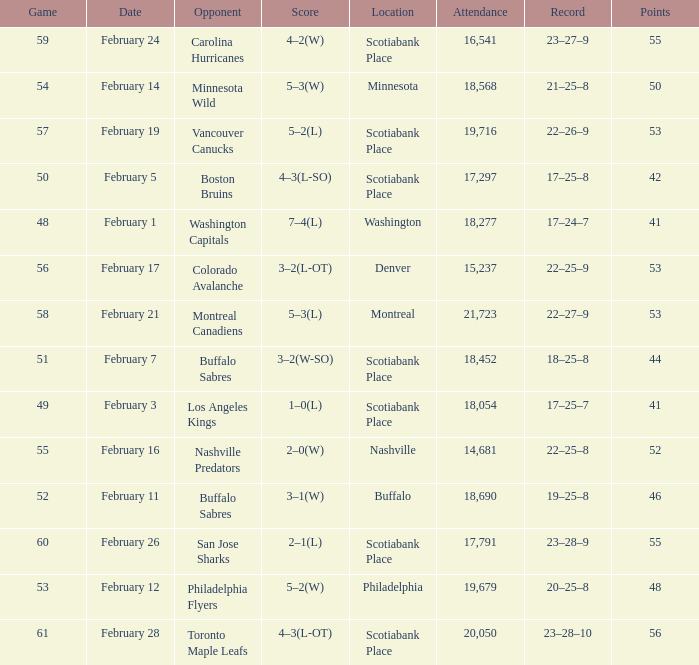What sum of game has an attendance of 18,690? 52.0. I'm looking to parse the entire table for insights. Could you assist me with that? {'header': ['Game', 'Date', 'Opponent', 'Score', 'Location', 'Attendance', 'Record', 'Points'], 'rows': [['59', 'February 24', 'Carolina Hurricanes', '4–2(W)', 'Scotiabank Place', '16,541', '23–27–9', '55'], ['54', 'February 14', 'Minnesota Wild', '5–3(W)', 'Minnesota', '18,568', '21–25–8', '50'], ['57', 'February 19', 'Vancouver Canucks', '5–2(L)', 'Scotiabank Place', '19,716', '22–26–9', '53'], ['50', 'February 5', 'Boston Bruins', '4–3(L-SO)', 'Scotiabank Place', '17,297', '17–25–8', '42'], ['48', 'February 1', 'Washington Capitals', '7–4(L)', 'Washington', '18,277', '17–24–7', '41'], ['56', 'February 17', 'Colorado Avalanche', '3–2(L-OT)', 'Denver', '15,237', '22–25–9', '53'], ['58', 'February 21', 'Montreal Canadiens', '5–3(L)', 'Montreal', '21,723', '22–27–9', '53'], ['51', 'February 7', 'Buffalo Sabres', '3–2(W-SO)', 'Scotiabank Place', '18,452', '18–25–8', '44'], ['49', 'February 3', 'Los Angeles Kings', '1–0(L)', 'Scotiabank Place', '18,054', '17–25–7', '41'], ['55', 'February 16', 'Nashville Predators', '2–0(W)', 'Nashville', '14,681', '22–25–8', '52'], ['52', 'February 11', 'Buffalo Sabres', '3–1(W)', 'Buffalo', '18,690', '19–25–8', '46'], ['60', 'February 26', 'San Jose Sharks', '2–1(L)', 'Scotiabank Place', '17,791', '23–28–9', '55'], ['53', 'February 12', 'Philadelphia Flyers', '5–2(W)', 'Philadelphia', '19,679', '20–25–8', '48'], ['61', 'February 28', 'Toronto Maple Leafs', '4–3(L-OT)', 'Scotiabank Place', '20,050', '23–28–10', '56']]} 